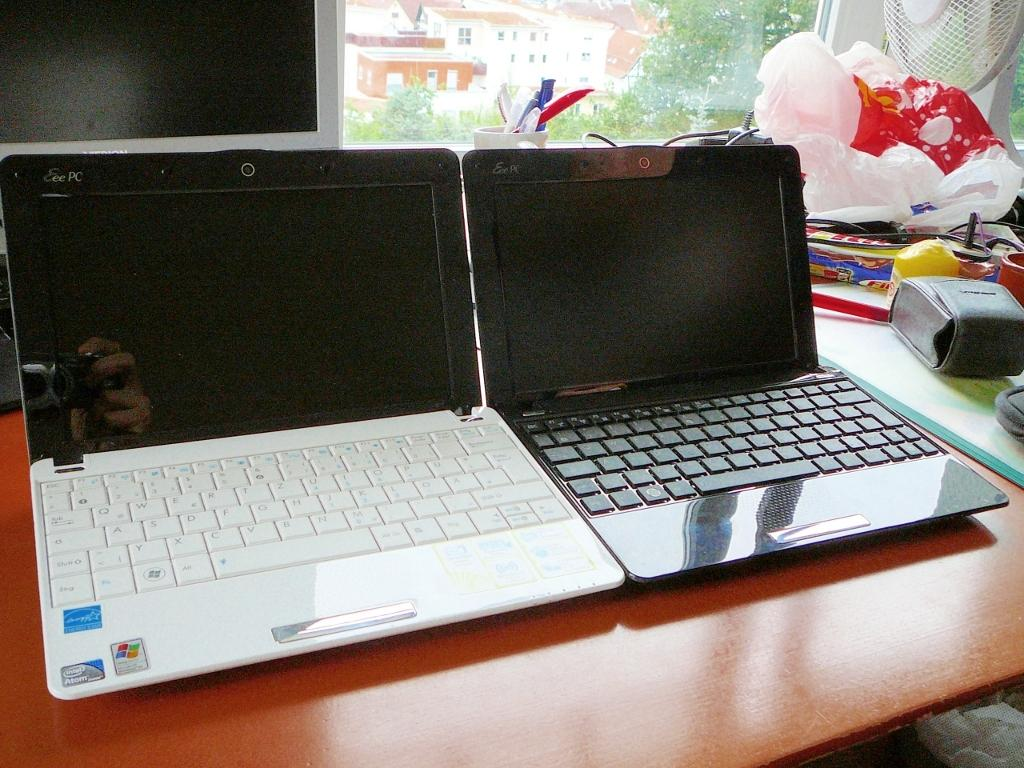What type of electronic devices can be seen in the image? There are laptops and a camera in the image. What items are used for covering or protecting in the image? There are covers in the image. What device is used for cooling in the image? There is a fan in the image. What type of reading material is present in the image? There are books in the image. What writing instruments can be seen in the image? There are pens in the image. What is the main object on which all these items are placed? All these objects are placed on a table. What can be seen in the background of the image? There is a window, buildings, and trees in the background of the image. What type of cheese is being used to hold the laptop in place in the image? There is no cheese present in the image, and the laptop is not being held in place by any cheese. 